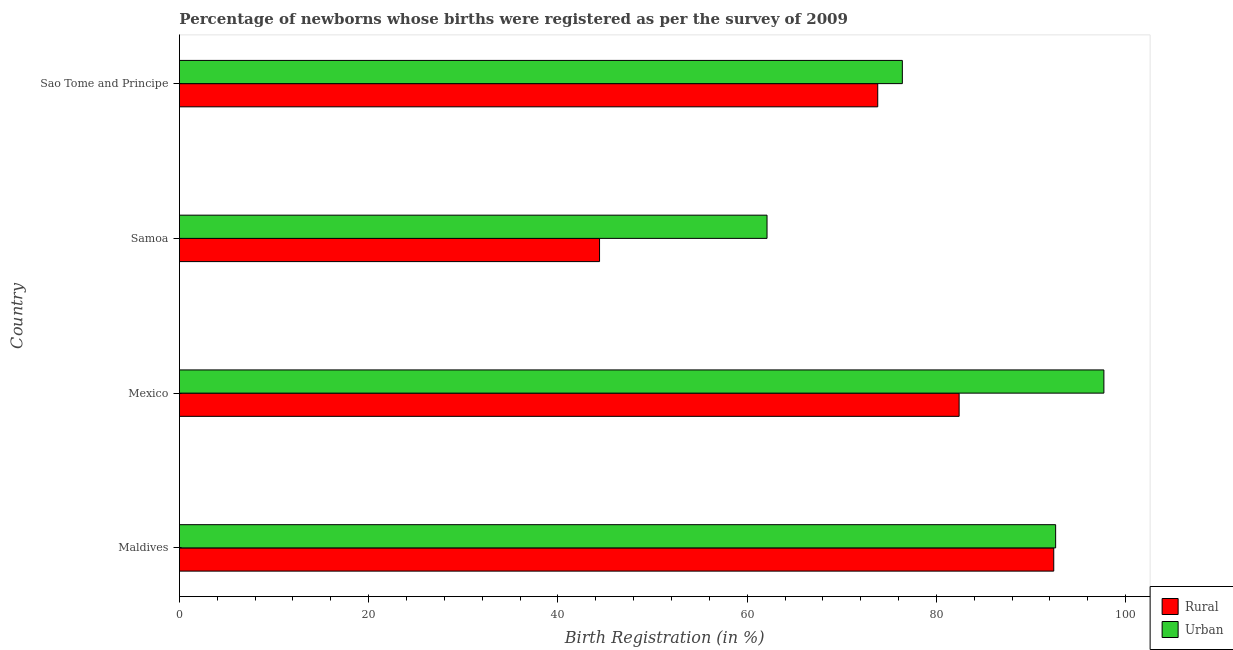Are the number of bars per tick equal to the number of legend labels?
Offer a terse response. Yes. Are the number of bars on each tick of the Y-axis equal?
Your answer should be very brief. Yes. How many bars are there on the 3rd tick from the top?
Your answer should be compact. 2. What is the label of the 4th group of bars from the top?
Keep it short and to the point. Maldives. What is the rural birth registration in Mexico?
Keep it short and to the point. 82.4. Across all countries, what is the maximum urban birth registration?
Ensure brevity in your answer.  97.7. Across all countries, what is the minimum rural birth registration?
Your answer should be very brief. 44.4. In which country was the urban birth registration minimum?
Your answer should be compact. Samoa. What is the total rural birth registration in the graph?
Give a very brief answer. 293. What is the difference between the rural birth registration in Maldives and that in Sao Tome and Principe?
Offer a very short reply. 18.6. What is the difference between the urban birth registration in Samoa and the rural birth registration in Maldives?
Your answer should be compact. -30.3. What is the average urban birth registration per country?
Make the answer very short. 82.2. What is the difference between the urban birth registration and rural birth registration in Sao Tome and Principe?
Offer a terse response. 2.6. What is the ratio of the rural birth registration in Samoa to that in Sao Tome and Principe?
Ensure brevity in your answer.  0.6. Is the urban birth registration in Maldives less than that in Samoa?
Your answer should be compact. No. What is the difference between the highest and the lowest urban birth registration?
Give a very brief answer. 35.6. What does the 1st bar from the top in Maldives represents?
Provide a succinct answer. Urban. What does the 1st bar from the bottom in Samoa represents?
Keep it short and to the point. Rural. How many countries are there in the graph?
Give a very brief answer. 4. Does the graph contain any zero values?
Make the answer very short. No. Where does the legend appear in the graph?
Offer a terse response. Bottom right. How many legend labels are there?
Your answer should be very brief. 2. How are the legend labels stacked?
Your answer should be compact. Vertical. What is the title of the graph?
Provide a short and direct response. Percentage of newborns whose births were registered as per the survey of 2009. Does "Arms imports" appear as one of the legend labels in the graph?
Provide a succinct answer. No. What is the label or title of the X-axis?
Ensure brevity in your answer.  Birth Registration (in %). What is the Birth Registration (in %) in Rural in Maldives?
Your answer should be compact. 92.4. What is the Birth Registration (in %) of Urban in Maldives?
Offer a terse response. 92.6. What is the Birth Registration (in %) of Rural in Mexico?
Your answer should be compact. 82.4. What is the Birth Registration (in %) in Urban in Mexico?
Give a very brief answer. 97.7. What is the Birth Registration (in %) in Rural in Samoa?
Your answer should be very brief. 44.4. What is the Birth Registration (in %) in Urban in Samoa?
Your response must be concise. 62.1. What is the Birth Registration (in %) of Rural in Sao Tome and Principe?
Provide a succinct answer. 73.8. What is the Birth Registration (in %) of Urban in Sao Tome and Principe?
Provide a short and direct response. 76.4. Across all countries, what is the maximum Birth Registration (in %) of Rural?
Your answer should be very brief. 92.4. Across all countries, what is the maximum Birth Registration (in %) of Urban?
Keep it short and to the point. 97.7. Across all countries, what is the minimum Birth Registration (in %) of Rural?
Offer a very short reply. 44.4. Across all countries, what is the minimum Birth Registration (in %) in Urban?
Offer a terse response. 62.1. What is the total Birth Registration (in %) in Rural in the graph?
Your response must be concise. 293. What is the total Birth Registration (in %) of Urban in the graph?
Make the answer very short. 328.8. What is the difference between the Birth Registration (in %) of Rural in Maldives and that in Samoa?
Your response must be concise. 48. What is the difference between the Birth Registration (in %) of Urban in Maldives and that in Samoa?
Give a very brief answer. 30.5. What is the difference between the Birth Registration (in %) of Rural in Maldives and that in Sao Tome and Principe?
Your response must be concise. 18.6. What is the difference between the Birth Registration (in %) in Urban in Maldives and that in Sao Tome and Principe?
Your response must be concise. 16.2. What is the difference between the Birth Registration (in %) in Rural in Mexico and that in Samoa?
Give a very brief answer. 38. What is the difference between the Birth Registration (in %) of Urban in Mexico and that in Samoa?
Offer a terse response. 35.6. What is the difference between the Birth Registration (in %) of Urban in Mexico and that in Sao Tome and Principe?
Keep it short and to the point. 21.3. What is the difference between the Birth Registration (in %) of Rural in Samoa and that in Sao Tome and Principe?
Provide a short and direct response. -29.4. What is the difference between the Birth Registration (in %) of Urban in Samoa and that in Sao Tome and Principe?
Make the answer very short. -14.3. What is the difference between the Birth Registration (in %) of Rural in Maldives and the Birth Registration (in %) of Urban in Samoa?
Keep it short and to the point. 30.3. What is the difference between the Birth Registration (in %) in Rural in Mexico and the Birth Registration (in %) in Urban in Samoa?
Provide a short and direct response. 20.3. What is the difference between the Birth Registration (in %) in Rural in Mexico and the Birth Registration (in %) in Urban in Sao Tome and Principe?
Provide a short and direct response. 6. What is the difference between the Birth Registration (in %) of Rural in Samoa and the Birth Registration (in %) of Urban in Sao Tome and Principe?
Provide a short and direct response. -32. What is the average Birth Registration (in %) in Rural per country?
Provide a succinct answer. 73.25. What is the average Birth Registration (in %) in Urban per country?
Your answer should be very brief. 82.2. What is the difference between the Birth Registration (in %) of Rural and Birth Registration (in %) of Urban in Mexico?
Give a very brief answer. -15.3. What is the difference between the Birth Registration (in %) in Rural and Birth Registration (in %) in Urban in Samoa?
Make the answer very short. -17.7. What is the ratio of the Birth Registration (in %) of Rural in Maldives to that in Mexico?
Your answer should be very brief. 1.12. What is the ratio of the Birth Registration (in %) of Urban in Maldives to that in Mexico?
Offer a terse response. 0.95. What is the ratio of the Birth Registration (in %) of Rural in Maldives to that in Samoa?
Make the answer very short. 2.08. What is the ratio of the Birth Registration (in %) in Urban in Maldives to that in Samoa?
Offer a terse response. 1.49. What is the ratio of the Birth Registration (in %) in Rural in Maldives to that in Sao Tome and Principe?
Your answer should be very brief. 1.25. What is the ratio of the Birth Registration (in %) in Urban in Maldives to that in Sao Tome and Principe?
Keep it short and to the point. 1.21. What is the ratio of the Birth Registration (in %) of Rural in Mexico to that in Samoa?
Ensure brevity in your answer.  1.86. What is the ratio of the Birth Registration (in %) of Urban in Mexico to that in Samoa?
Provide a short and direct response. 1.57. What is the ratio of the Birth Registration (in %) of Rural in Mexico to that in Sao Tome and Principe?
Offer a terse response. 1.12. What is the ratio of the Birth Registration (in %) in Urban in Mexico to that in Sao Tome and Principe?
Offer a terse response. 1.28. What is the ratio of the Birth Registration (in %) of Rural in Samoa to that in Sao Tome and Principe?
Offer a very short reply. 0.6. What is the ratio of the Birth Registration (in %) of Urban in Samoa to that in Sao Tome and Principe?
Your answer should be compact. 0.81. What is the difference between the highest and the lowest Birth Registration (in %) in Urban?
Provide a short and direct response. 35.6. 